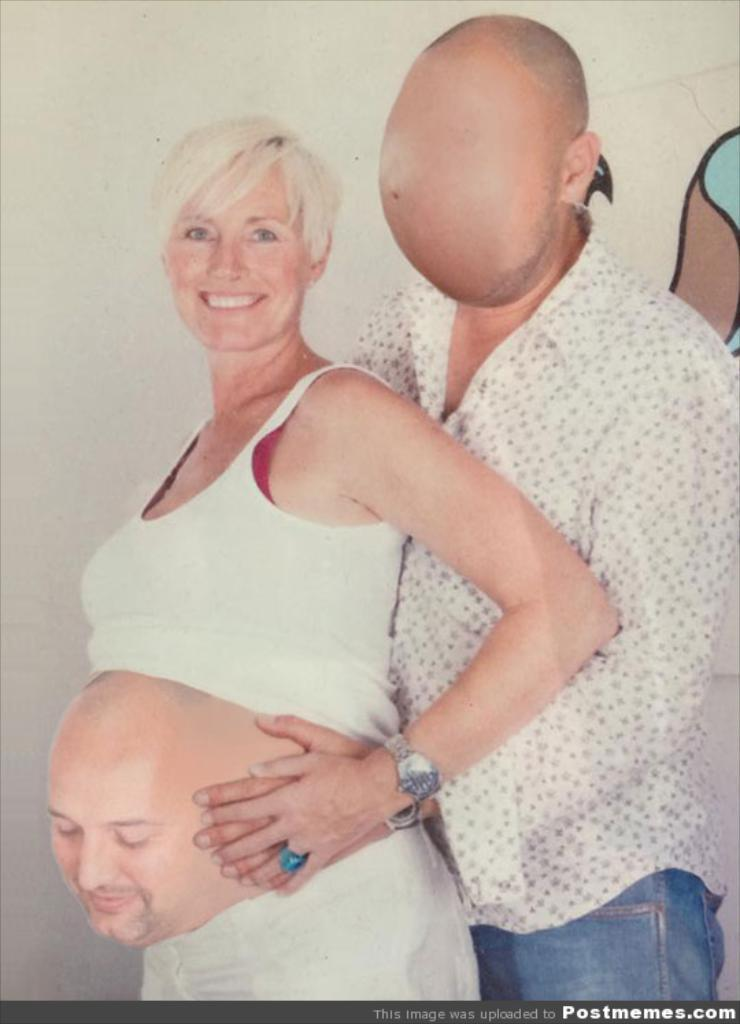How many people are in the image? There are two persons in the image. What is the person on the right wearing? The person on the right is wearing a white shirt and blue pants. What is the person on the left wearing? The person on the left is wearing a white dress. What can be seen in the background of the image? The background of the image includes a white wall. What type of clouds can be seen in the image? There are no clouds visible in the image; the background is a white wall. 